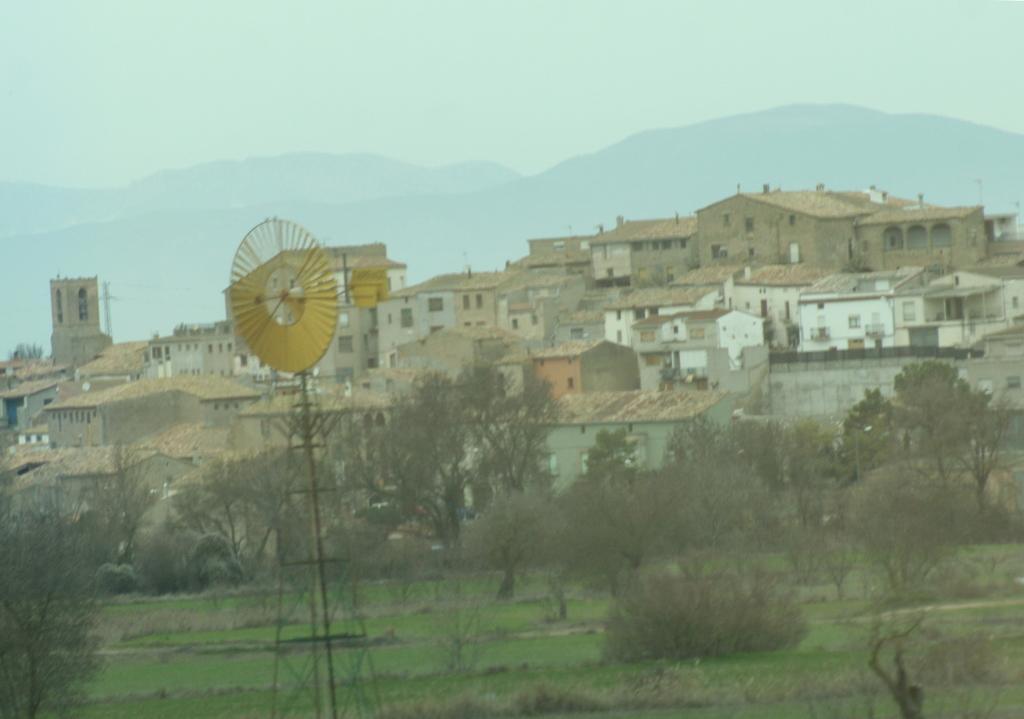Please provide a concise description of this image. In the foreground we can see a windmill on the stand. In the center of the image we can see a group of trees, buildings with windows and roofs. In the background we can see, mountains and the sky. 